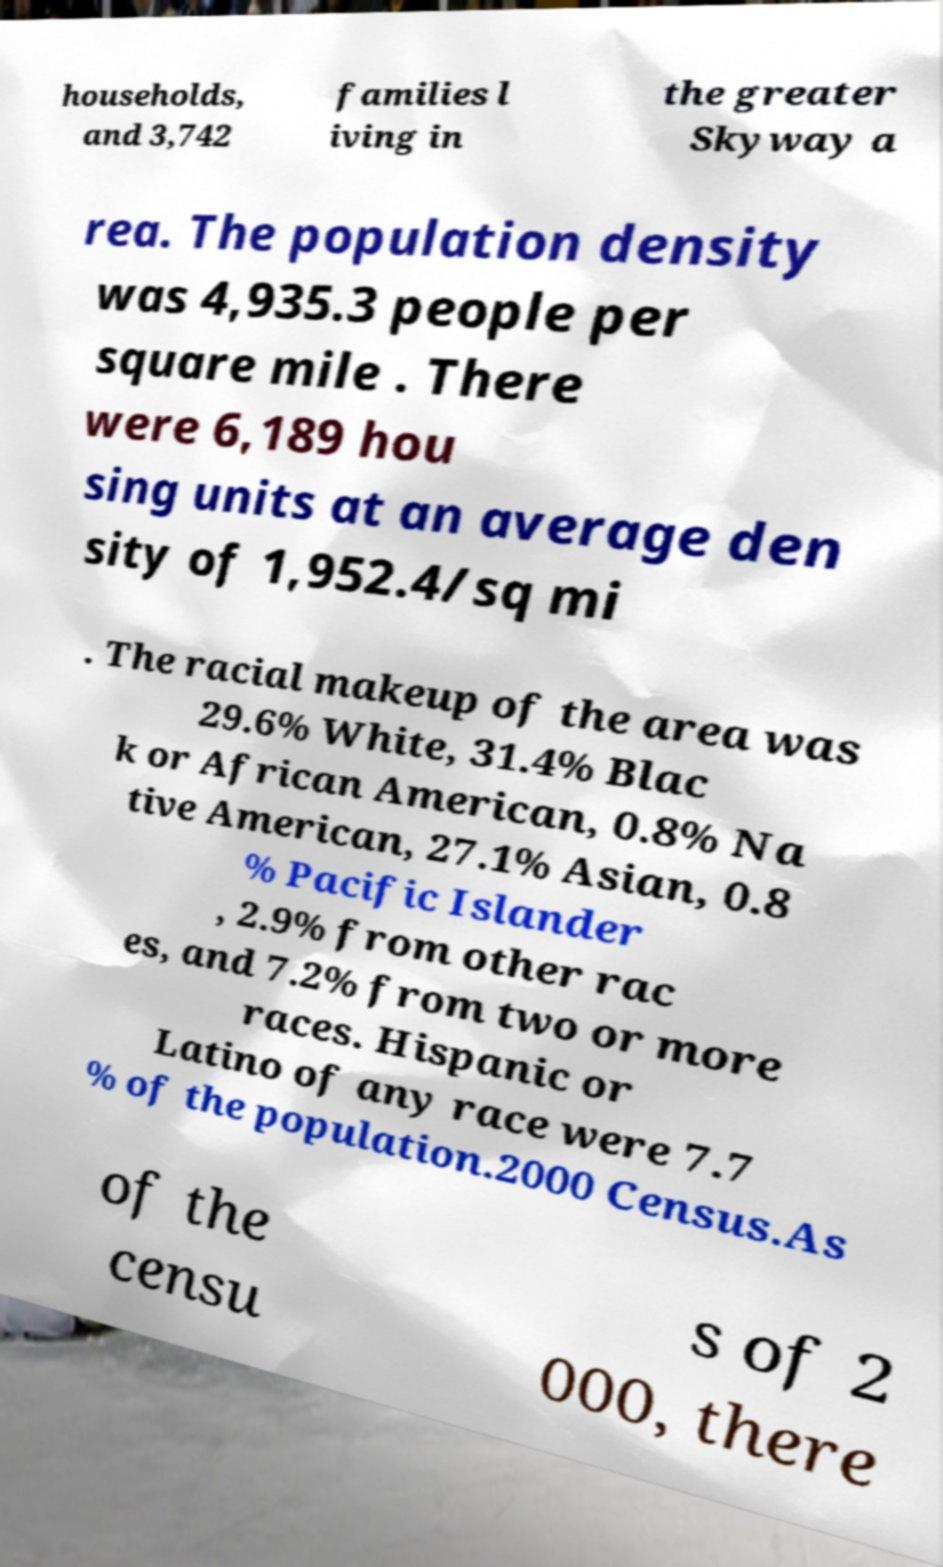I need the written content from this picture converted into text. Can you do that? households, and 3,742 families l iving in the greater Skyway a rea. The population density was 4,935.3 people per square mile . There were 6,189 hou sing units at an average den sity of 1,952.4/sq mi . The racial makeup of the area was 29.6% White, 31.4% Blac k or African American, 0.8% Na tive American, 27.1% Asian, 0.8 % Pacific Islander , 2.9% from other rac es, and 7.2% from two or more races. Hispanic or Latino of any race were 7.7 % of the population.2000 Census.As of the censu s of 2 000, there 